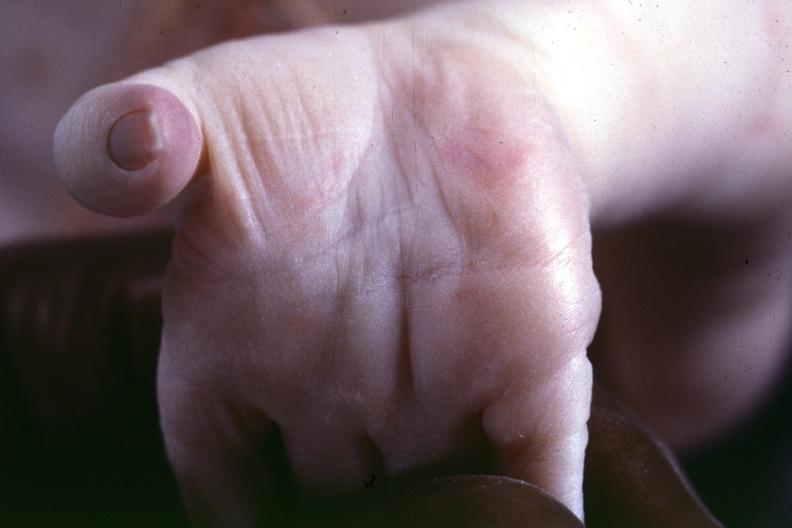what is a simian crease suspect?
Answer the question using a single word or phrase. Previous slide from this case 